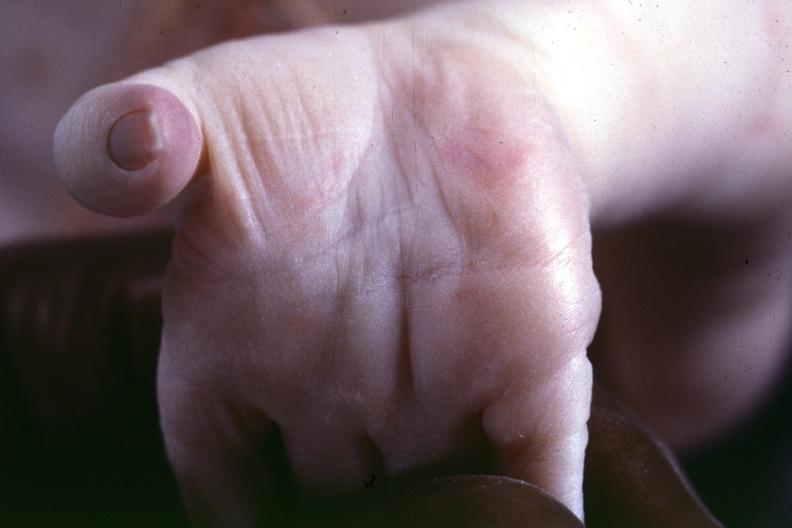what is a simian crease suspect?
Answer the question using a single word or phrase. Previous slide from this case 